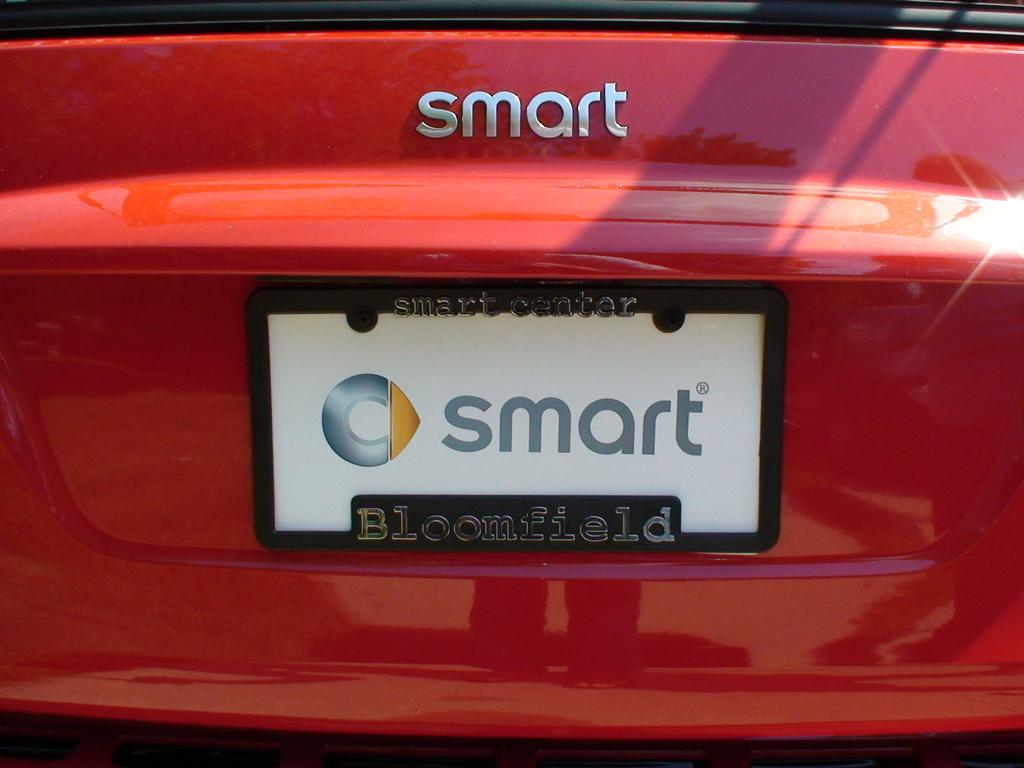<image>
Offer a succinct explanation of the picture presented. A red car says smart on the back. 